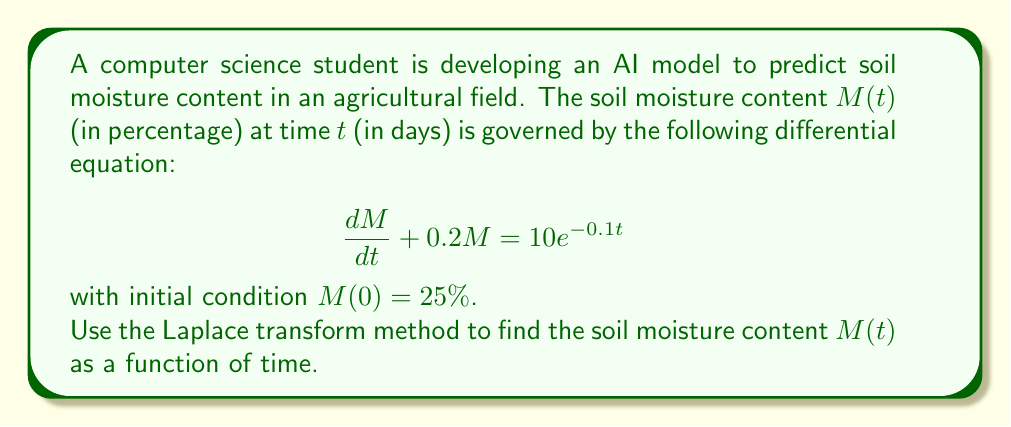Provide a solution to this math problem. Let's solve this problem step by step using the Laplace transform method:

1) First, let's take the Laplace transform of both sides of the differential equation:

   $\mathcal{L}\{\frac{dM}{dt} + 0.2M\} = \mathcal{L}\{10e^{-0.1t}\}$

2) Using the linearity property and the Laplace transform of the derivative:

   $s\mathcal{L}\{M\} - M(0) + 0.2\mathcal{L}\{M\} = \frac{10}{s+0.1}$

3) Let $\mathcal{L}\{M\} = X(s)$. Substituting the initial condition $M(0) = 25$:

   $sX(s) - 25 + 0.2X(s) = \frac{10}{s+0.1}$

4) Factoring out $X(s)$:

   $(s + 0.2)X(s) = 25 + \frac{10}{s+0.1}$

5) Solving for $X(s)$:

   $X(s) = \frac{25}{s + 0.2} + \frac{10}{(s + 0.2)(s + 0.1)}$

6) Using partial fraction decomposition on the second term:

   $\frac{10}{(s + 0.2)(s + 0.1)} = \frac{A}{s + 0.2} + \frac{B}{s + 0.1}$

   where $A = \frac{10}{0.1} = 100$ and $B = \frac{-10}{0.1} = -100$

7) Therefore:

   $X(s) = \frac{25}{s + 0.2} + \frac{100}{s + 0.2} - \frac{100}{s + 0.1}$

8) Taking the inverse Laplace transform:

   $M(t) = 125e^{-0.2t} - 100e^{-0.1t}$

This is the solution for the soil moisture content as a function of time.
Answer: $M(t) = 125e^{-0.2t} - 100e^{-0.1t}$ 